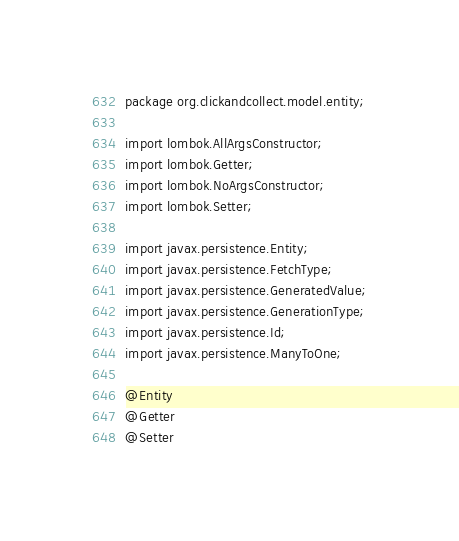Convert code to text. <code><loc_0><loc_0><loc_500><loc_500><_Java_>package org.clickandcollect.model.entity;

import lombok.AllArgsConstructor;
import lombok.Getter;
import lombok.NoArgsConstructor;
import lombok.Setter;

import javax.persistence.Entity;
import javax.persistence.FetchType;
import javax.persistence.GeneratedValue;
import javax.persistence.GenerationType;
import javax.persistence.Id;
import javax.persistence.ManyToOne;

@Entity
@Getter
@Setter</code> 